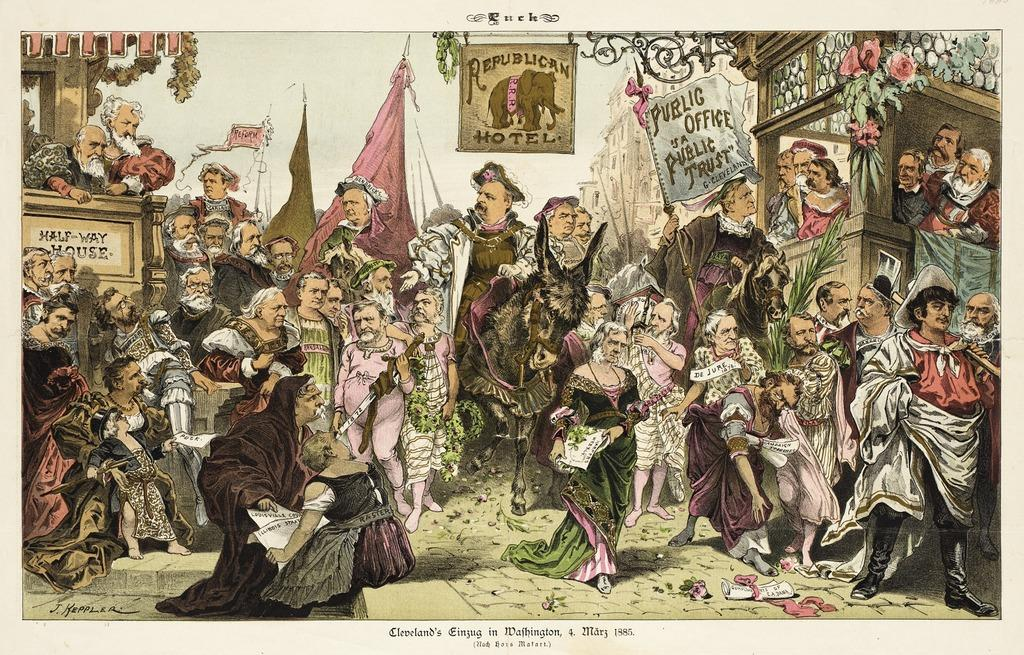<image>
Create a compact narrative representing the image presented. an oldtimey style political drawing of a lot of people with Republican Motel on one of the banners. 